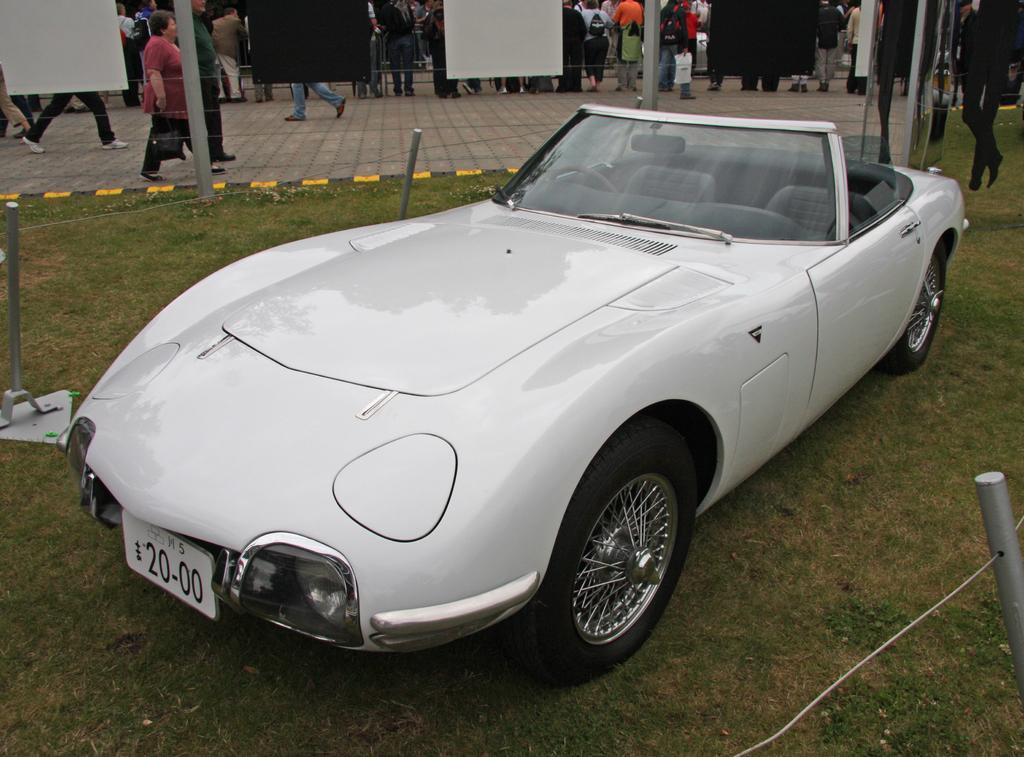Please provide a concise description of this image. As we can see in the image there is a white color car, grass, posters and few people here and there. 